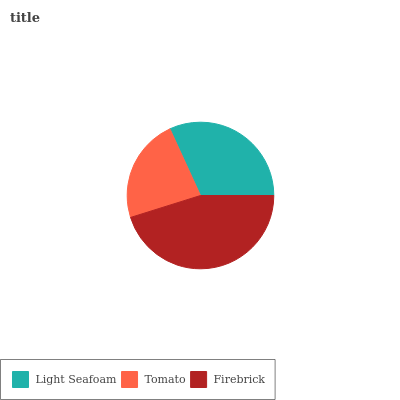Is Tomato the minimum?
Answer yes or no. Yes. Is Firebrick the maximum?
Answer yes or no. Yes. Is Firebrick the minimum?
Answer yes or no. No. Is Tomato the maximum?
Answer yes or no. No. Is Firebrick greater than Tomato?
Answer yes or no. Yes. Is Tomato less than Firebrick?
Answer yes or no. Yes. Is Tomato greater than Firebrick?
Answer yes or no. No. Is Firebrick less than Tomato?
Answer yes or no. No. Is Light Seafoam the high median?
Answer yes or no. Yes. Is Light Seafoam the low median?
Answer yes or no. Yes. Is Firebrick the high median?
Answer yes or no. No. Is Tomato the low median?
Answer yes or no. No. 